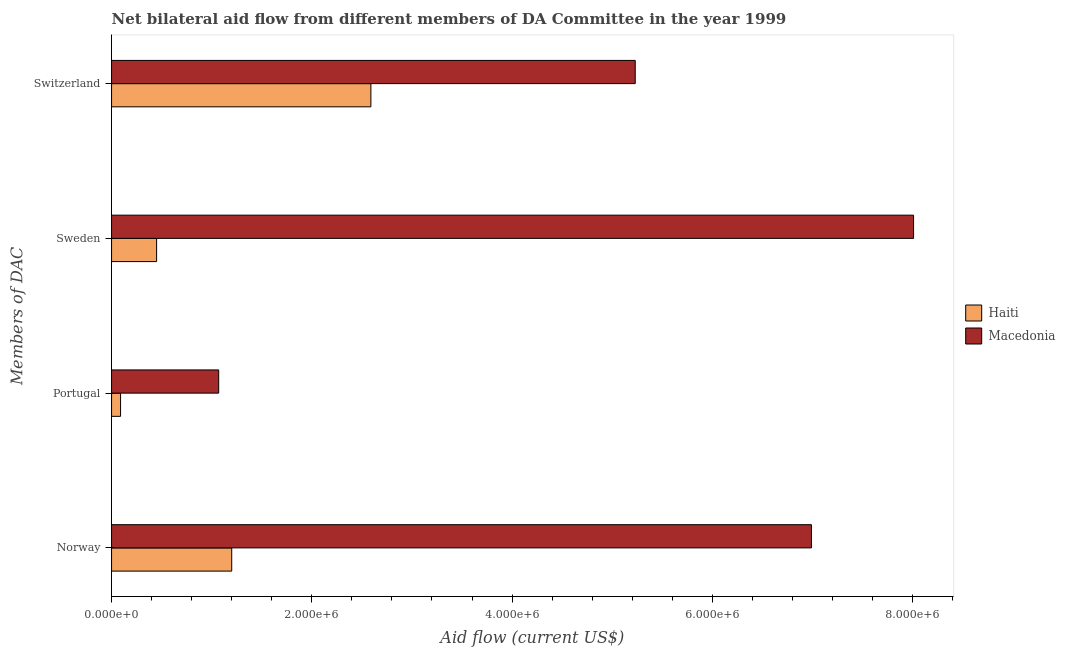How many groups of bars are there?
Make the answer very short. 4. Are the number of bars per tick equal to the number of legend labels?
Your answer should be very brief. Yes. Are the number of bars on each tick of the Y-axis equal?
Your response must be concise. Yes. How many bars are there on the 4th tick from the top?
Keep it short and to the point. 2. How many bars are there on the 2nd tick from the bottom?
Offer a very short reply. 2. What is the amount of aid given by switzerland in Macedonia?
Your response must be concise. 5.23e+06. Across all countries, what is the maximum amount of aid given by sweden?
Provide a short and direct response. 8.01e+06. Across all countries, what is the minimum amount of aid given by sweden?
Ensure brevity in your answer.  4.50e+05. In which country was the amount of aid given by portugal maximum?
Ensure brevity in your answer.  Macedonia. In which country was the amount of aid given by switzerland minimum?
Your answer should be compact. Haiti. What is the total amount of aid given by norway in the graph?
Keep it short and to the point. 8.19e+06. What is the difference between the amount of aid given by portugal in Haiti and that in Macedonia?
Offer a very short reply. -9.80e+05. What is the difference between the amount of aid given by sweden in Haiti and the amount of aid given by norway in Macedonia?
Offer a terse response. -6.54e+06. What is the average amount of aid given by sweden per country?
Offer a terse response. 4.23e+06. What is the difference between the amount of aid given by portugal and amount of aid given by norway in Macedonia?
Your answer should be very brief. -5.92e+06. What is the ratio of the amount of aid given by portugal in Haiti to that in Macedonia?
Your response must be concise. 0.08. What is the difference between the highest and the second highest amount of aid given by switzerland?
Ensure brevity in your answer.  2.64e+06. What is the difference between the highest and the lowest amount of aid given by switzerland?
Your answer should be compact. 2.64e+06. In how many countries, is the amount of aid given by norway greater than the average amount of aid given by norway taken over all countries?
Ensure brevity in your answer.  1. Is the sum of the amount of aid given by switzerland in Macedonia and Haiti greater than the maximum amount of aid given by norway across all countries?
Make the answer very short. Yes. What does the 2nd bar from the top in Norway represents?
Offer a very short reply. Haiti. What does the 1st bar from the bottom in Portugal represents?
Your answer should be compact. Haiti. How many countries are there in the graph?
Your answer should be compact. 2. What is the difference between two consecutive major ticks on the X-axis?
Offer a very short reply. 2.00e+06. Does the graph contain grids?
Ensure brevity in your answer.  No. How many legend labels are there?
Offer a very short reply. 2. How are the legend labels stacked?
Your answer should be very brief. Vertical. What is the title of the graph?
Give a very brief answer. Net bilateral aid flow from different members of DA Committee in the year 1999. What is the label or title of the Y-axis?
Make the answer very short. Members of DAC. What is the Aid flow (current US$) of Haiti in Norway?
Offer a very short reply. 1.20e+06. What is the Aid flow (current US$) in Macedonia in Norway?
Your answer should be very brief. 6.99e+06. What is the Aid flow (current US$) of Macedonia in Portugal?
Offer a very short reply. 1.07e+06. What is the Aid flow (current US$) in Haiti in Sweden?
Your answer should be compact. 4.50e+05. What is the Aid flow (current US$) in Macedonia in Sweden?
Provide a succinct answer. 8.01e+06. What is the Aid flow (current US$) of Haiti in Switzerland?
Offer a very short reply. 2.59e+06. What is the Aid flow (current US$) in Macedonia in Switzerland?
Your answer should be very brief. 5.23e+06. Across all Members of DAC, what is the maximum Aid flow (current US$) in Haiti?
Offer a very short reply. 2.59e+06. Across all Members of DAC, what is the maximum Aid flow (current US$) in Macedonia?
Ensure brevity in your answer.  8.01e+06. Across all Members of DAC, what is the minimum Aid flow (current US$) in Macedonia?
Provide a short and direct response. 1.07e+06. What is the total Aid flow (current US$) of Haiti in the graph?
Offer a very short reply. 4.33e+06. What is the total Aid flow (current US$) of Macedonia in the graph?
Give a very brief answer. 2.13e+07. What is the difference between the Aid flow (current US$) of Haiti in Norway and that in Portugal?
Offer a terse response. 1.11e+06. What is the difference between the Aid flow (current US$) of Macedonia in Norway and that in Portugal?
Give a very brief answer. 5.92e+06. What is the difference between the Aid flow (current US$) in Haiti in Norway and that in Sweden?
Ensure brevity in your answer.  7.50e+05. What is the difference between the Aid flow (current US$) of Macedonia in Norway and that in Sweden?
Provide a short and direct response. -1.02e+06. What is the difference between the Aid flow (current US$) of Haiti in Norway and that in Switzerland?
Make the answer very short. -1.39e+06. What is the difference between the Aid flow (current US$) of Macedonia in Norway and that in Switzerland?
Your response must be concise. 1.76e+06. What is the difference between the Aid flow (current US$) of Haiti in Portugal and that in Sweden?
Give a very brief answer. -3.60e+05. What is the difference between the Aid flow (current US$) of Macedonia in Portugal and that in Sweden?
Provide a succinct answer. -6.94e+06. What is the difference between the Aid flow (current US$) in Haiti in Portugal and that in Switzerland?
Offer a very short reply. -2.50e+06. What is the difference between the Aid flow (current US$) of Macedonia in Portugal and that in Switzerland?
Provide a short and direct response. -4.16e+06. What is the difference between the Aid flow (current US$) of Haiti in Sweden and that in Switzerland?
Make the answer very short. -2.14e+06. What is the difference between the Aid flow (current US$) of Macedonia in Sweden and that in Switzerland?
Keep it short and to the point. 2.78e+06. What is the difference between the Aid flow (current US$) in Haiti in Norway and the Aid flow (current US$) in Macedonia in Sweden?
Make the answer very short. -6.81e+06. What is the difference between the Aid flow (current US$) in Haiti in Norway and the Aid flow (current US$) in Macedonia in Switzerland?
Your answer should be compact. -4.03e+06. What is the difference between the Aid flow (current US$) of Haiti in Portugal and the Aid flow (current US$) of Macedonia in Sweden?
Your answer should be very brief. -7.92e+06. What is the difference between the Aid flow (current US$) in Haiti in Portugal and the Aid flow (current US$) in Macedonia in Switzerland?
Offer a terse response. -5.14e+06. What is the difference between the Aid flow (current US$) of Haiti in Sweden and the Aid flow (current US$) of Macedonia in Switzerland?
Your answer should be compact. -4.78e+06. What is the average Aid flow (current US$) of Haiti per Members of DAC?
Give a very brief answer. 1.08e+06. What is the average Aid flow (current US$) in Macedonia per Members of DAC?
Provide a succinct answer. 5.32e+06. What is the difference between the Aid flow (current US$) in Haiti and Aid flow (current US$) in Macedonia in Norway?
Keep it short and to the point. -5.79e+06. What is the difference between the Aid flow (current US$) of Haiti and Aid flow (current US$) of Macedonia in Portugal?
Provide a succinct answer. -9.80e+05. What is the difference between the Aid flow (current US$) in Haiti and Aid flow (current US$) in Macedonia in Sweden?
Offer a very short reply. -7.56e+06. What is the difference between the Aid flow (current US$) of Haiti and Aid flow (current US$) of Macedonia in Switzerland?
Make the answer very short. -2.64e+06. What is the ratio of the Aid flow (current US$) of Haiti in Norway to that in Portugal?
Offer a very short reply. 13.33. What is the ratio of the Aid flow (current US$) of Macedonia in Norway to that in Portugal?
Offer a terse response. 6.53. What is the ratio of the Aid flow (current US$) of Haiti in Norway to that in Sweden?
Your answer should be compact. 2.67. What is the ratio of the Aid flow (current US$) of Macedonia in Norway to that in Sweden?
Ensure brevity in your answer.  0.87. What is the ratio of the Aid flow (current US$) in Haiti in Norway to that in Switzerland?
Your answer should be very brief. 0.46. What is the ratio of the Aid flow (current US$) in Macedonia in Norway to that in Switzerland?
Keep it short and to the point. 1.34. What is the ratio of the Aid flow (current US$) of Haiti in Portugal to that in Sweden?
Your response must be concise. 0.2. What is the ratio of the Aid flow (current US$) of Macedonia in Portugal to that in Sweden?
Ensure brevity in your answer.  0.13. What is the ratio of the Aid flow (current US$) in Haiti in Portugal to that in Switzerland?
Your answer should be very brief. 0.03. What is the ratio of the Aid flow (current US$) in Macedonia in Portugal to that in Switzerland?
Give a very brief answer. 0.2. What is the ratio of the Aid flow (current US$) in Haiti in Sweden to that in Switzerland?
Give a very brief answer. 0.17. What is the ratio of the Aid flow (current US$) of Macedonia in Sweden to that in Switzerland?
Your answer should be compact. 1.53. What is the difference between the highest and the second highest Aid flow (current US$) in Haiti?
Make the answer very short. 1.39e+06. What is the difference between the highest and the second highest Aid flow (current US$) in Macedonia?
Keep it short and to the point. 1.02e+06. What is the difference between the highest and the lowest Aid flow (current US$) in Haiti?
Make the answer very short. 2.50e+06. What is the difference between the highest and the lowest Aid flow (current US$) in Macedonia?
Provide a short and direct response. 6.94e+06. 